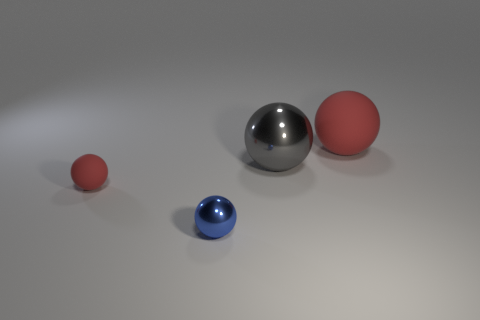How many red spheres must be subtracted to get 1 red spheres? 1 Add 3 metallic balls. How many objects exist? 7 Subtract 0 red cubes. How many objects are left? 4 Subtract all tiny metallic balls. Subtract all big shiny objects. How many objects are left? 2 Add 3 large shiny things. How many large shiny things are left? 4 Add 2 large gray metallic things. How many large gray metallic things exist? 3 